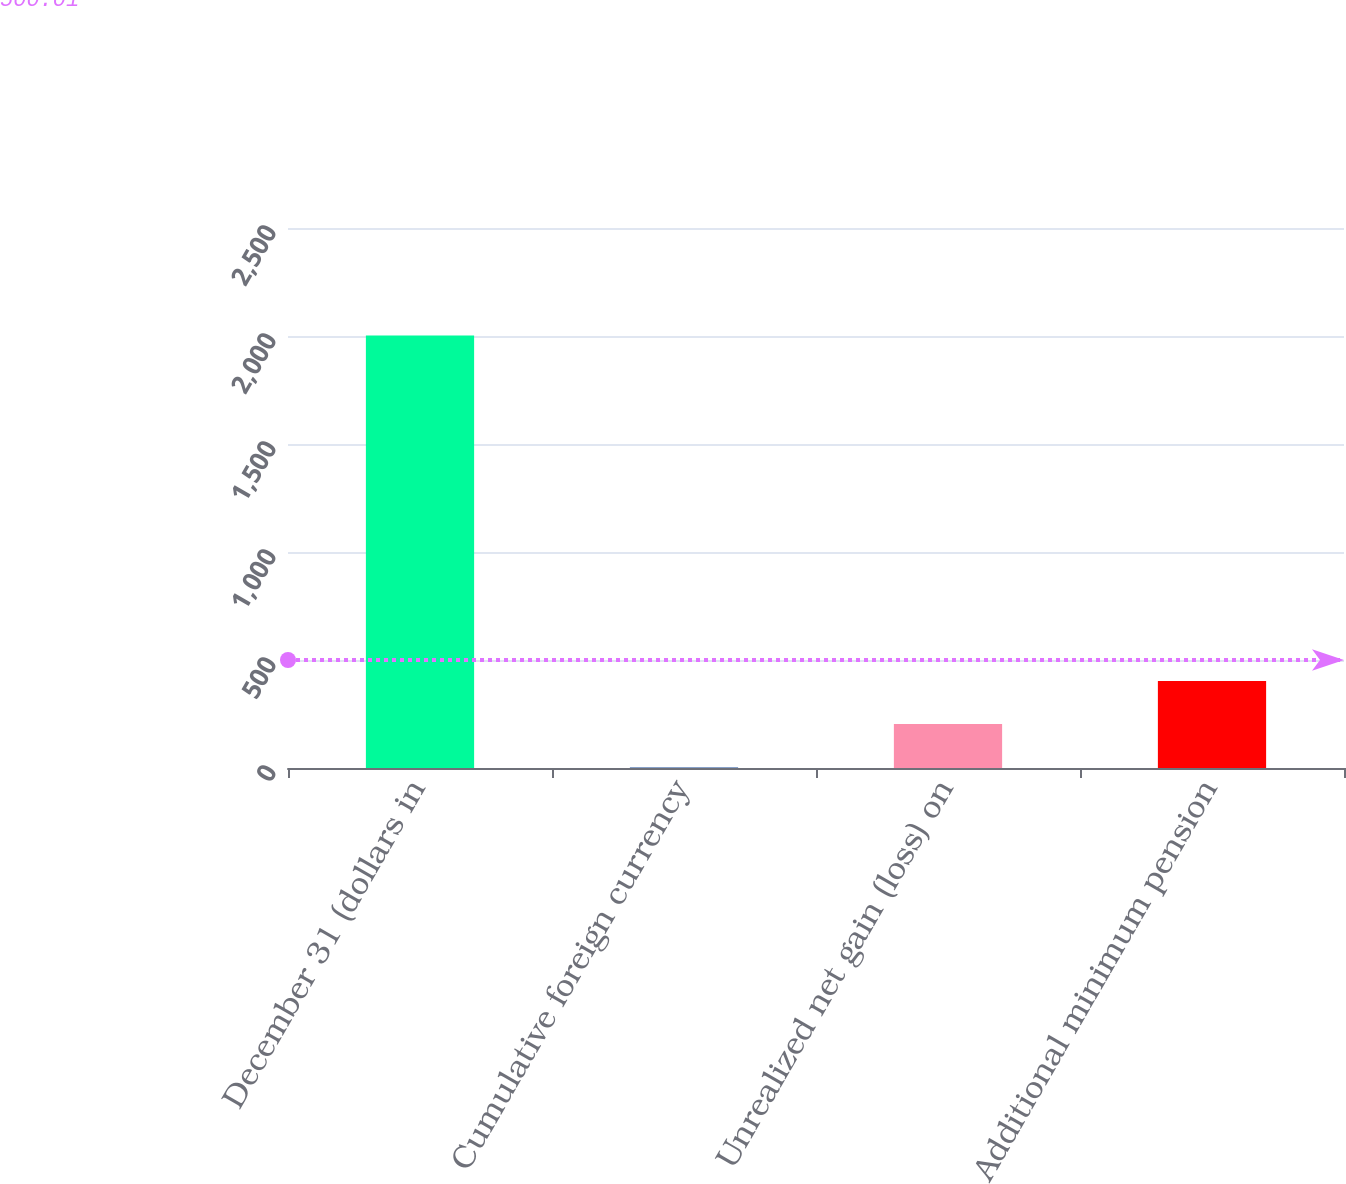<chart> <loc_0><loc_0><loc_500><loc_500><bar_chart><fcel>December 31 (dollars in<fcel>Cumulative foreign currency<fcel>Unrealized net gain (loss) on<fcel>Additional minimum pension<nl><fcel>2002<fcel>3.4<fcel>203.26<fcel>403.12<nl></chart> 